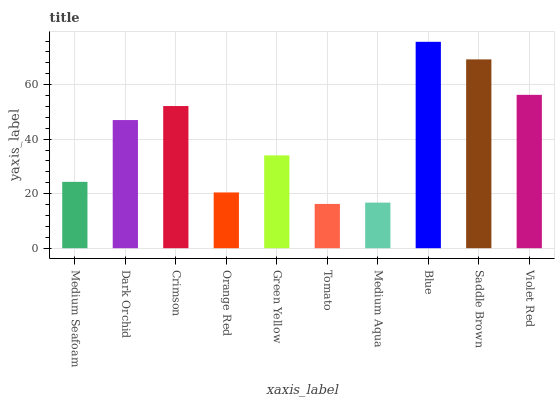Is Dark Orchid the minimum?
Answer yes or no. No. Is Dark Orchid the maximum?
Answer yes or no. No. Is Dark Orchid greater than Medium Seafoam?
Answer yes or no. Yes. Is Medium Seafoam less than Dark Orchid?
Answer yes or no. Yes. Is Medium Seafoam greater than Dark Orchid?
Answer yes or no. No. Is Dark Orchid less than Medium Seafoam?
Answer yes or no. No. Is Dark Orchid the high median?
Answer yes or no. Yes. Is Green Yellow the low median?
Answer yes or no. Yes. Is Saddle Brown the high median?
Answer yes or no. No. Is Blue the low median?
Answer yes or no. No. 